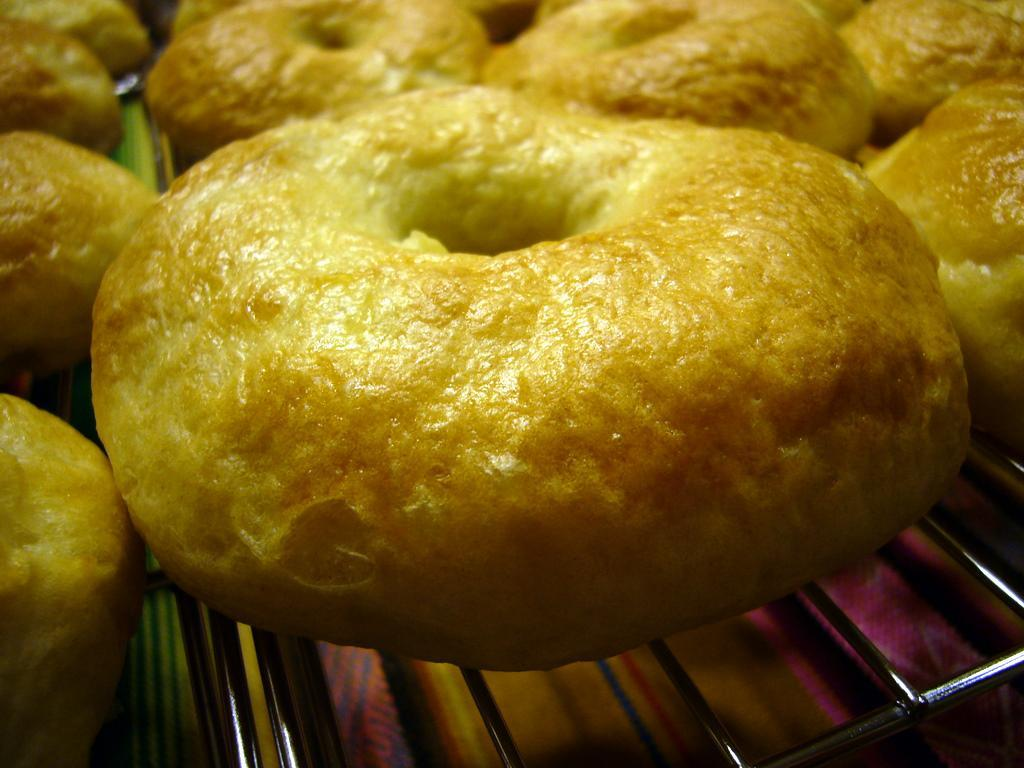What is being cooked or prepared in the image? There are snacks on a grill in the image. How many children are playing with the invention in the image? There are no children or inventions present in the image; it only features snacks on a grill. What type of squirrel can be seen climbing the grill in the image? There is no squirrel present in the image; it only features snacks on a grill. 